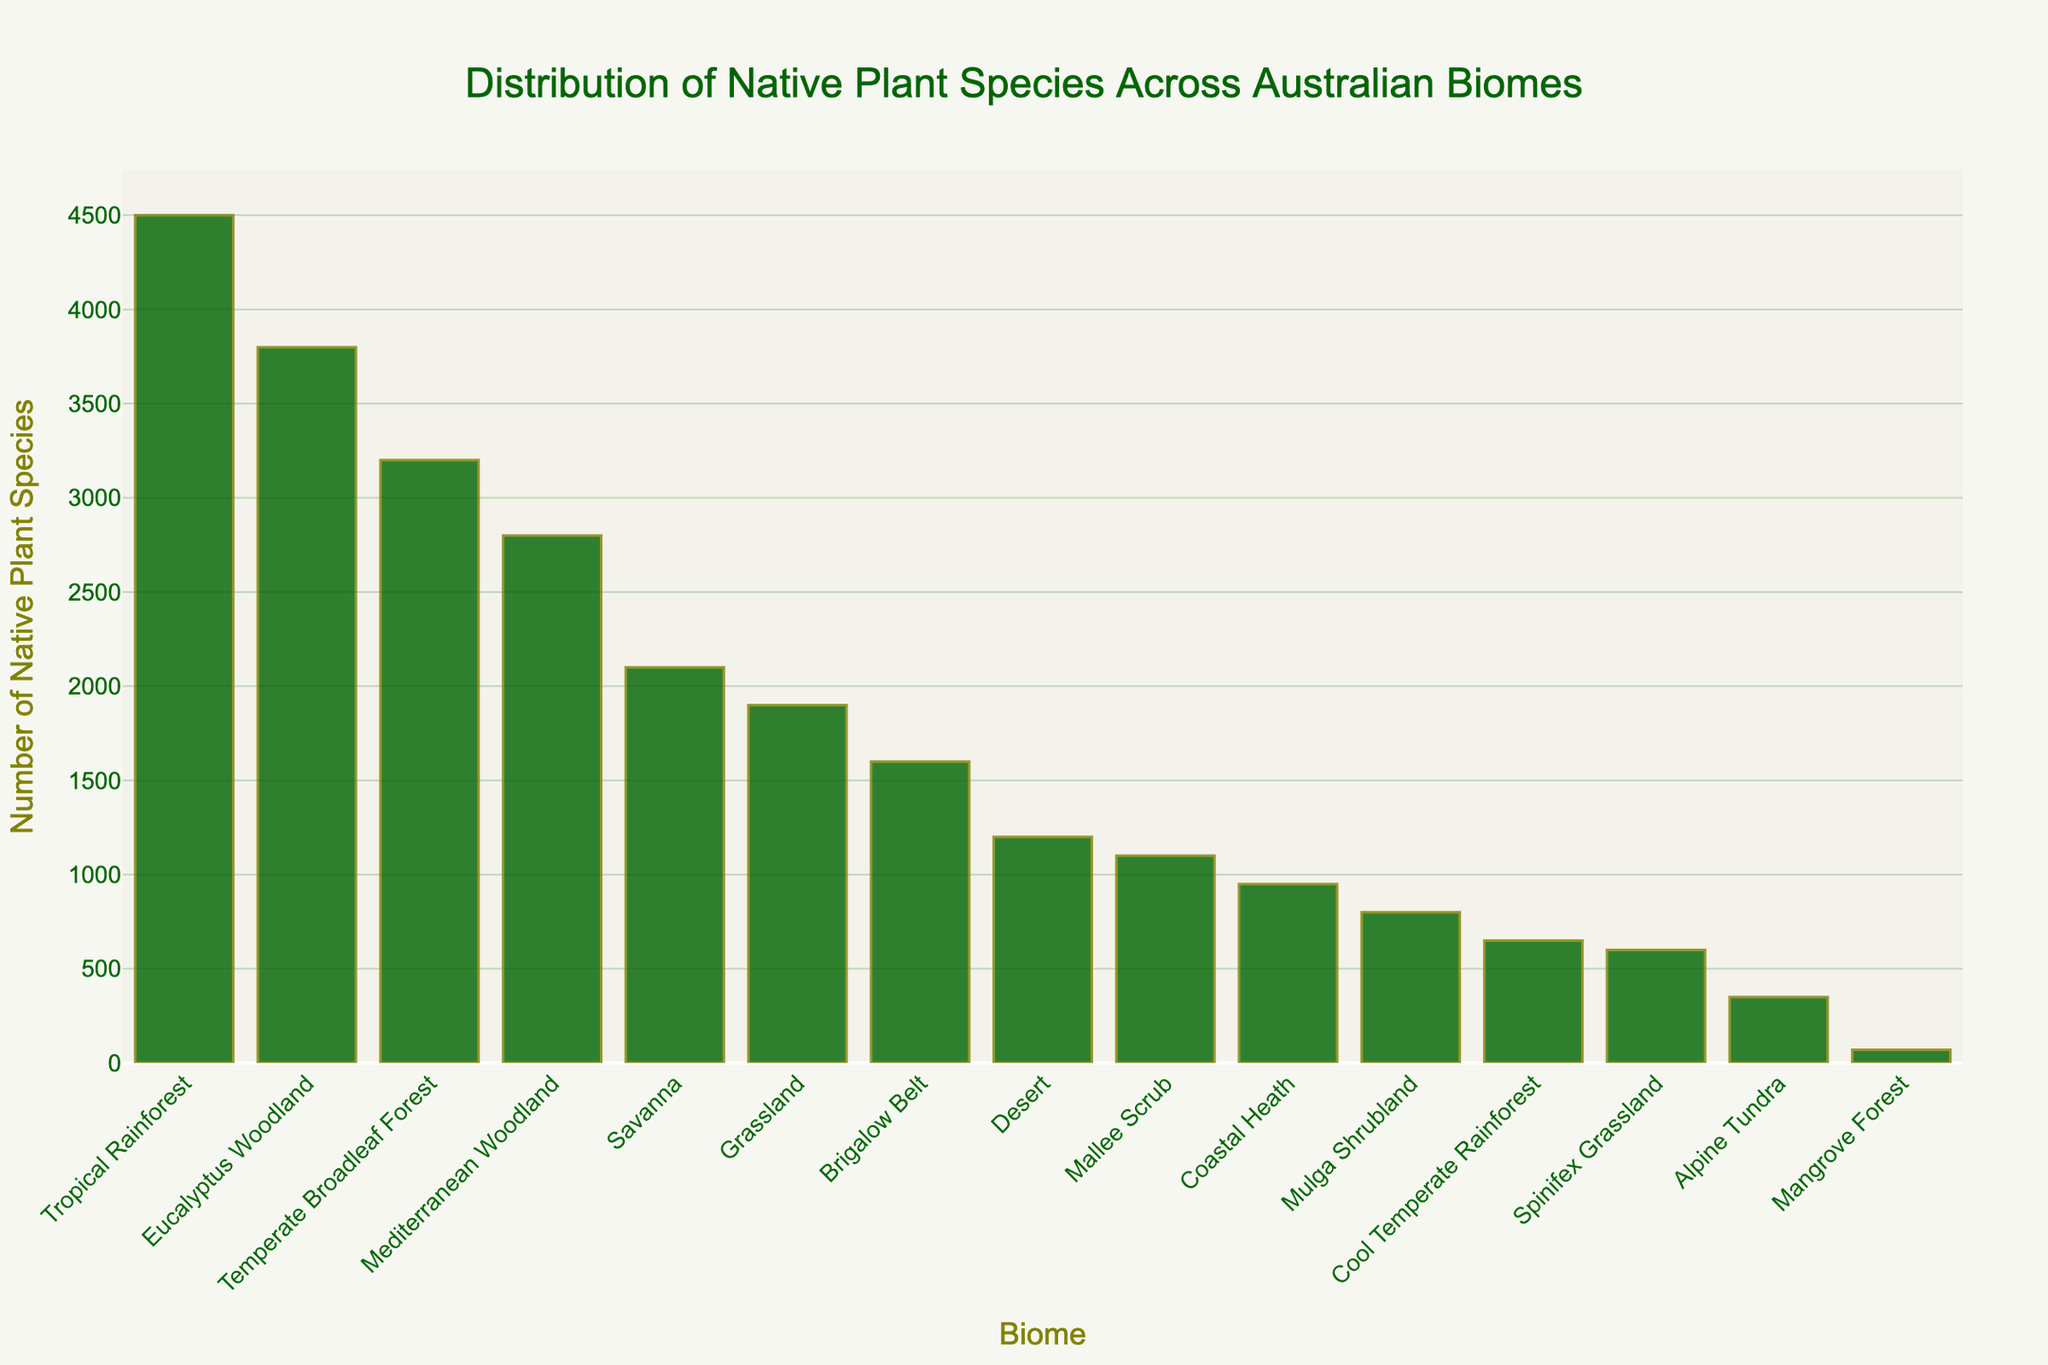Which biome has the highest number of native plant species? The tallest bar in the chart can help identify the biome with the highest number of native plant species. By looking at the height of the bars, we see that the "Tropical Rainforest" biome has the highest bar.
Answer: Tropical Rainforest What is the difference in the number of native plant species between the Tropical Rainforest and the Mangrove Forest biomes? The Tropical Rainforest biome has 4500 native plant species, and the Mangrove Forest biome has 70. To find the difference, subtract 70 from 4500.
Answer: 4430 Which biomes have less than 1000 native plant species? We need to identify all bars that are lower than the 1000 species mark. These biomes are "Mangrove Forest," "Alpine Tundra," "Spinifex Grassland," "Cool Temperate Rainforest," and "Mulga Shrubland."
Answer: Mangrove Forest, Alpine Tundra, Spinifex Grassland, Cool Temperate Rainforest, Mulga Shrubland How many native plant species are there in the Eucalyptus Woodland and Brigalow Belt biomes combined? The Eucalyptus Woodland biome has 3800 native plant species, and the Brigalow Belt biome has 1600. Add these two numbers together to find the total.
Answer: 5400 What is the average number of native plant species for the Coastal Heath, Grassland, and Desert biomes? Coastal Heath has 950 species, Grassland has 1900 species, and Desert has 1200 species. Add these (950 + 1900 + 1200 = 4050) and divide by 3 (4050 / 3).
Answer: 1350 Which biomes have more native plant species, Temperate Broadleaf Forest or Eucalyptus Woodland? Compare the heights of the respective bars. Temperate Broadleaf Forest has 3200 species, and Eucalyptus Woodland has 3800 species. Eucalyptus Woodland has more native plant species.
Answer: Eucalyptus Woodland Among the biomes shown, which one has the least number of native plant species and how many? The shortest bar indicates the biome with the least number of native plant species. That is the "Mangrove Forest" with 70 species.
Answer: Mangrove Forest, 70 What is the total number of native plant species for biomes that have more than 3000 species each? Identify the biomes with more than 3000 species: Tropical Rainforest (4500), Temperate Broadleaf Forest (3200), and Eucalyptus Woodland (3800). Sum these numbers (4500 + 3200 + 3800).
Answer: 11500 How many biomes have between 1000 and 2000 native plant species? Count the bars whose heights correspond to values between 1000 and 2000. These are Grassland (1900), Brigalow Belt (1600), Mulga Shrubland (800), and Mallee Scrub (1100).
Answer: 2 Which biome has nearly one-third the number of native plant species found in the Tropical Rainforest biome? The Tropical Rainforest biome has 4500 species. One-third of 4500 is roughly 1500. Brigalow Belt matches this criterion with 1600 species.
Answer: Brigalow Belt 